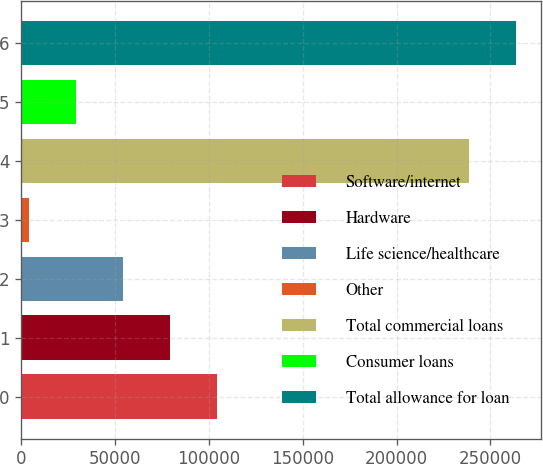Convert chart. <chart><loc_0><loc_0><loc_500><loc_500><bar_chart><fcel>Software/internet<fcel>Hardware<fcel>Life science/healthcare<fcel>Other<fcel>Total commercial loans<fcel>Consumer loans<fcel>Total allowance for loan<nl><fcel>104374<fcel>79265.9<fcel>54157.6<fcel>3941<fcel>238583<fcel>29049.3<fcel>263691<nl></chart> 